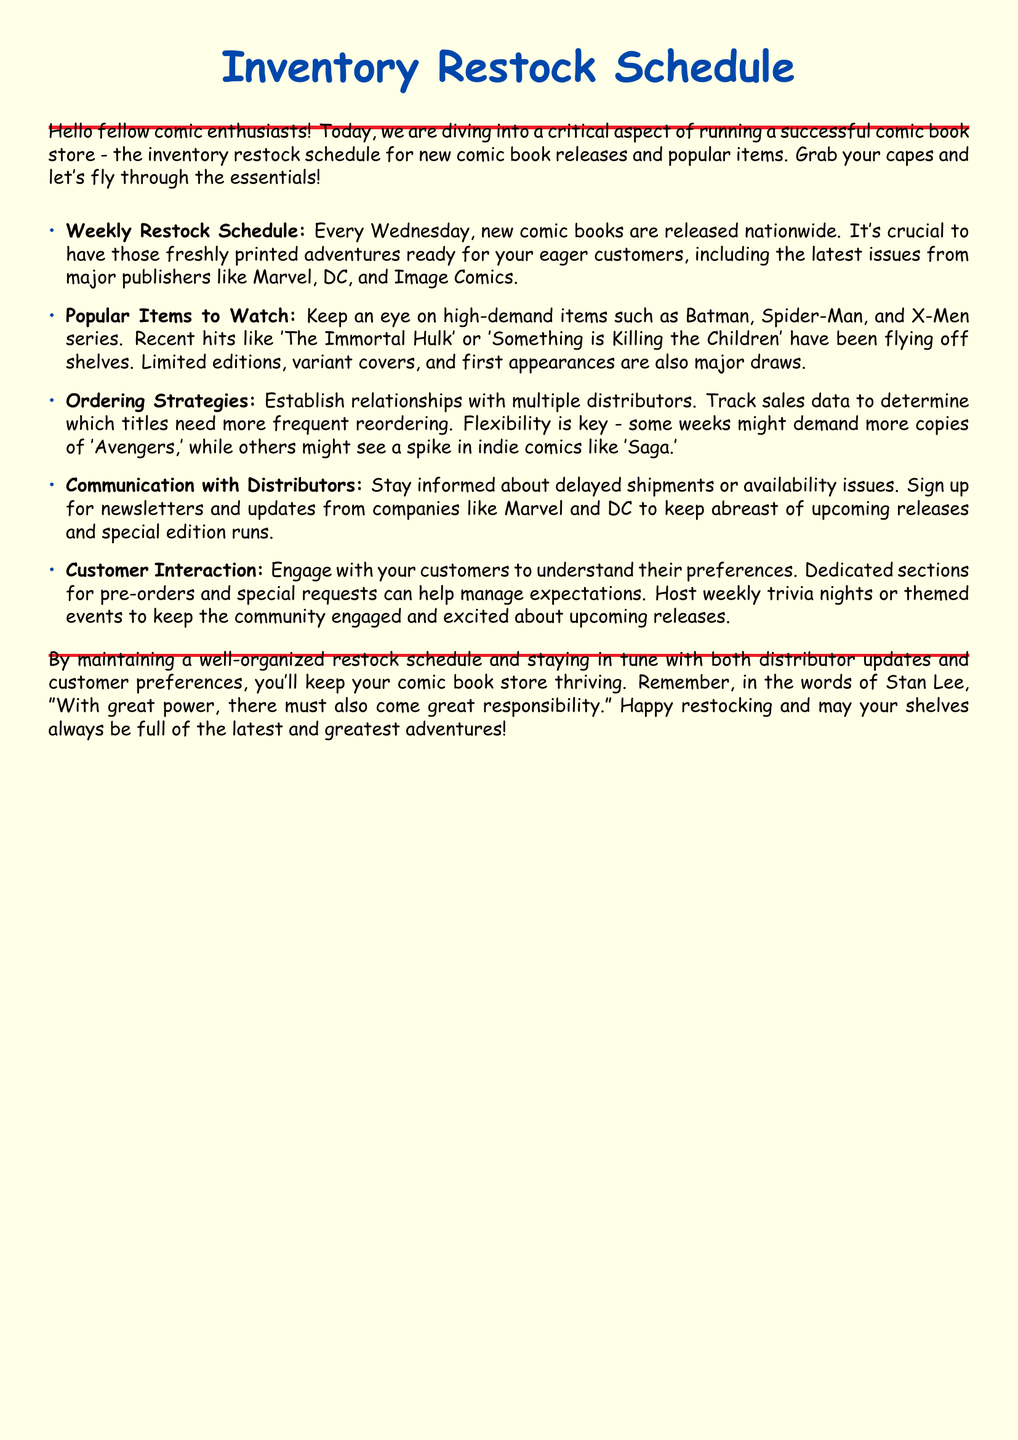What day are new comic books released? The document states that new comic books are released every Wednesday.
Answer: Wednesday Which publisher's latest issues are specifically mentioned? The document mentions major publishers including Marvel, DC, and Image Comics.
Answer: Marvel, DC, and Image Comics What are two high-demand items mentioned? The document lists Batman and Spider-Man as high-demand items to watch.
Answer: Batman and Spider-Man What is an example of a recent hit comic mentioned? The document cites 'The Immortal Hulk' and 'Something is Killing the Children' as recent hits.
Answer: The Immortal Hulk What is a strategy for ordering discussed in the document? Establishing relationships with multiple distributors is suggested as a strategy for ordering.
Answer: Establish relationships with multiple distributors How often should a comic store check for delayed shipments? The document advises staying informed about delayed shipments or availability issues continually.
Answer: Continually What type of interactions are encouraged with customers? Engaging with customers to understand their preferences is emphasized in the document.
Answer: Engage with customers According to the document, what should be hosted weekly to keep the community engaged? The document recommends hosting weekly trivia nights or themed events.
Answer: Trivia nights or themed events 